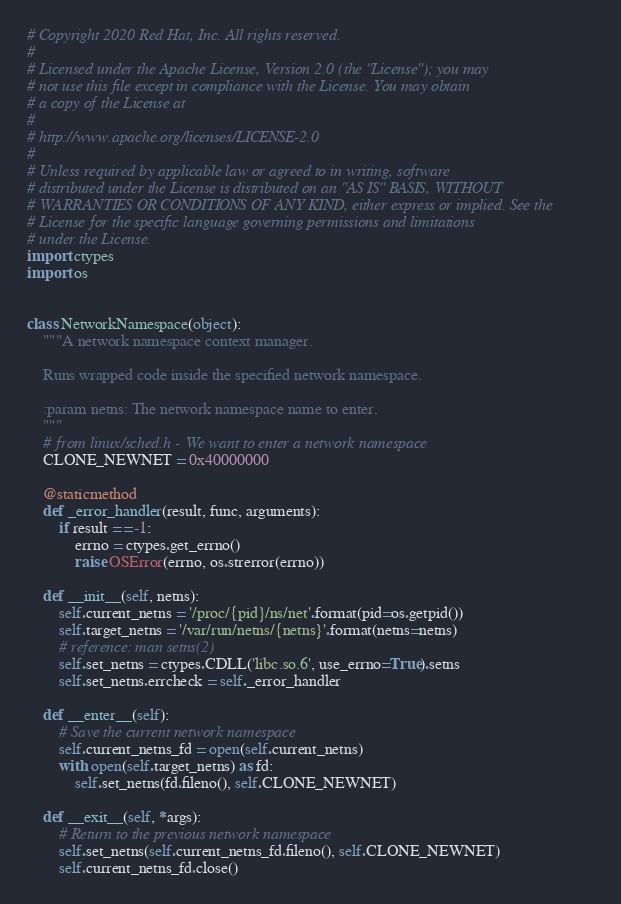<code> <loc_0><loc_0><loc_500><loc_500><_Python_># Copyright 2020 Red Hat, Inc. All rights reserved.
#
# Licensed under the Apache License, Version 2.0 (the "License"); you may
# not use this file except in compliance with the License. You may obtain
# a copy of the License at
#
# http://www.apache.org/licenses/LICENSE-2.0
#
# Unless required by applicable law or agreed to in writing, software
# distributed under the License is distributed on an "AS IS" BASIS, WITHOUT
# WARRANTIES OR CONDITIONS OF ANY KIND, either express or implied. See the
# License for the specific language governing permissions and limitations
# under the License.
import ctypes
import os


class NetworkNamespace(object):
    """A network namespace context manager.

    Runs wrapped code inside the specified network namespace.

    :param netns: The network namespace name to enter.
    """
    # from linux/sched.h - We want to enter a network namespace
    CLONE_NEWNET = 0x40000000

    @staticmethod
    def _error_handler(result, func, arguments):
        if result == -1:
            errno = ctypes.get_errno()
            raise OSError(errno, os.strerror(errno))

    def __init__(self, netns):
        self.current_netns = '/proc/{pid}/ns/net'.format(pid=os.getpid())
        self.target_netns = '/var/run/netns/{netns}'.format(netns=netns)
        # reference: man setns(2)
        self.set_netns = ctypes.CDLL('libc.so.6', use_errno=True).setns
        self.set_netns.errcheck = self._error_handler

    def __enter__(self):
        # Save the current network namespace
        self.current_netns_fd = open(self.current_netns)
        with open(self.target_netns) as fd:
            self.set_netns(fd.fileno(), self.CLONE_NEWNET)

    def __exit__(self, *args):
        # Return to the previous network namespace
        self.set_netns(self.current_netns_fd.fileno(), self.CLONE_NEWNET)
        self.current_netns_fd.close()
</code> 